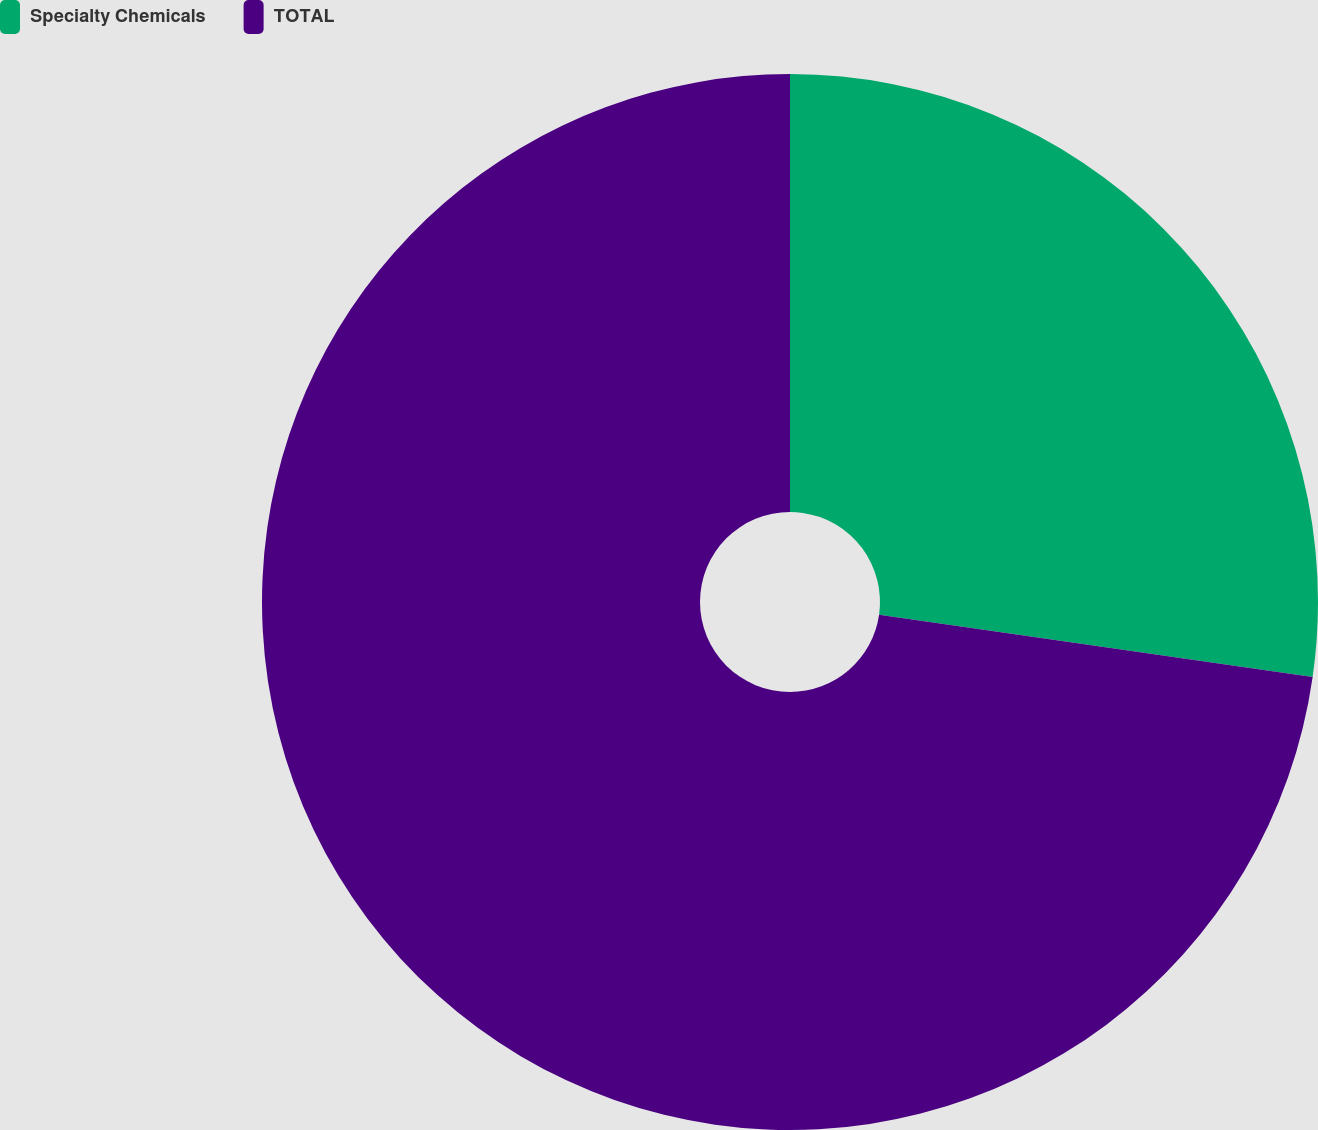<chart> <loc_0><loc_0><loc_500><loc_500><pie_chart><fcel>Specialty Chemicals<fcel>TOTAL<nl><fcel>27.27%<fcel>72.73%<nl></chart> 